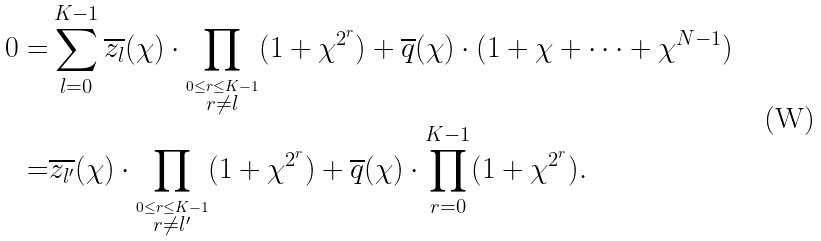<formula> <loc_0><loc_0><loc_500><loc_500>0 = & \sum _ { l = 0 } ^ { K - 1 } \overline { z _ { l } } ( \chi ) \cdot \prod _ { \stackrel { 0 \leq r \leq K - 1 } { r \neq l } } ( 1 + \chi ^ { 2 ^ { r } } ) + \overline { q } ( \chi ) \cdot ( 1 + \chi + \cdots + \chi ^ { N - 1 } ) \\ = & \overline { z _ { l ^ { \prime } } } ( \chi ) \cdot \prod _ { \stackrel { 0 \leq r \leq K - 1 } { r \neq l ^ { \prime } } } ( 1 + \chi ^ { 2 ^ { r } } ) + \overline { q } ( \chi ) \cdot \prod _ { r = 0 } ^ { K - 1 } ( 1 + \chi ^ { 2 ^ { r } } ) .</formula> 